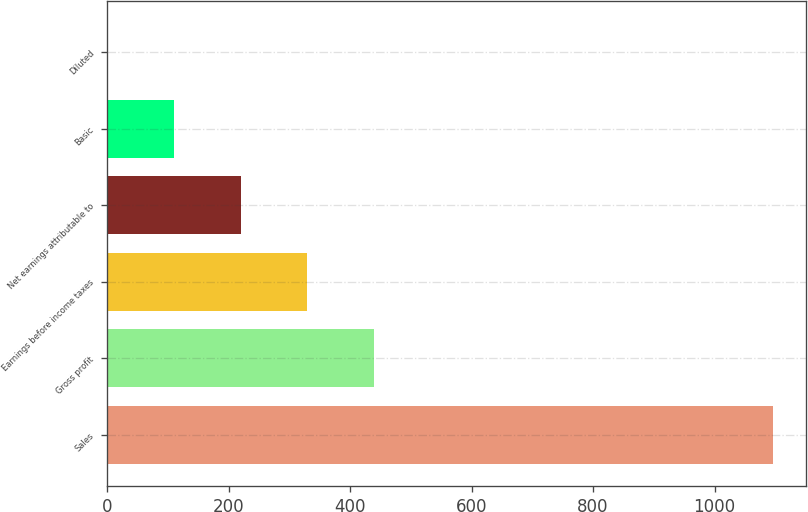<chart> <loc_0><loc_0><loc_500><loc_500><bar_chart><fcel>Sales<fcel>Gross profit<fcel>Earnings before income taxes<fcel>Net earnings attributable to<fcel>Basic<fcel>Diluted<nl><fcel>1096.6<fcel>439.03<fcel>329.44<fcel>219.85<fcel>110.26<fcel>0.67<nl></chart> 